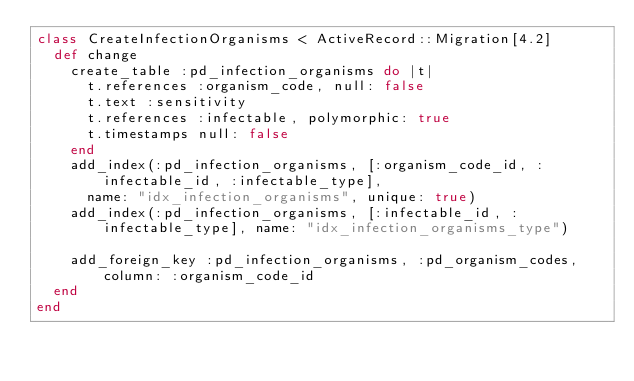Convert code to text. <code><loc_0><loc_0><loc_500><loc_500><_Ruby_>class CreateInfectionOrganisms < ActiveRecord::Migration[4.2]
  def change
    create_table :pd_infection_organisms do |t|
      t.references :organism_code, null: false
      t.text :sensitivity
      t.references :infectable, polymorphic: true
      t.timestamps null: false
    end
    add_index(:pd_infection_organisms, [:organism_code_id, :infectable_id, :infectable_type],
      name: "idx_infection_organisms", unique: true)
    add_index(:pd_infection_organisms, [:infectable_id, :infectable_type], name: "idx_infection_organisms_type")

    add_foreign_key :pd_infection_organisms, :pd_organism_codes, column: :organism_code_id
  end
end
</code> 